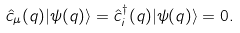<formula> <loc_0><loc_0><loc_500><loc_500>\hat { c } _ { \mu } ( q ) | \psi ( q ) \rangle = \hat { c } _ { i } ^ { \dag } ( q ) | \psi ( q ) \rangle = 0 .</formula> 